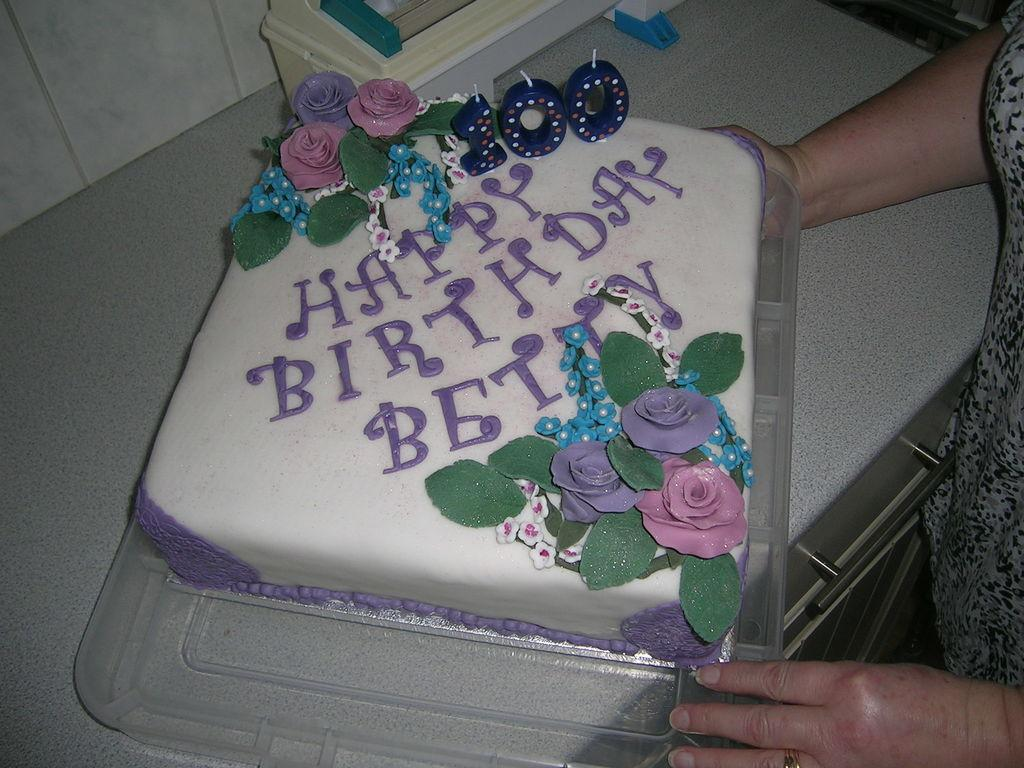What is the main object on the tray in the image? There is a cake on a tray in the image. What is placed on top of the cake? The cake has candles on it. Can you describe the object in the image? There is an object in the image, but its description is not provided in the facts. Is there a person visible in the image? Yes, there is a person standing in the image. What direction is the person facing in the image? The direction the person is facing is not mentioned in the facts, so it cannot be determined from the image. Can you tell me how many lizards are crawling on the cake? There are no lizards present in the image; the cake has candles on it. 